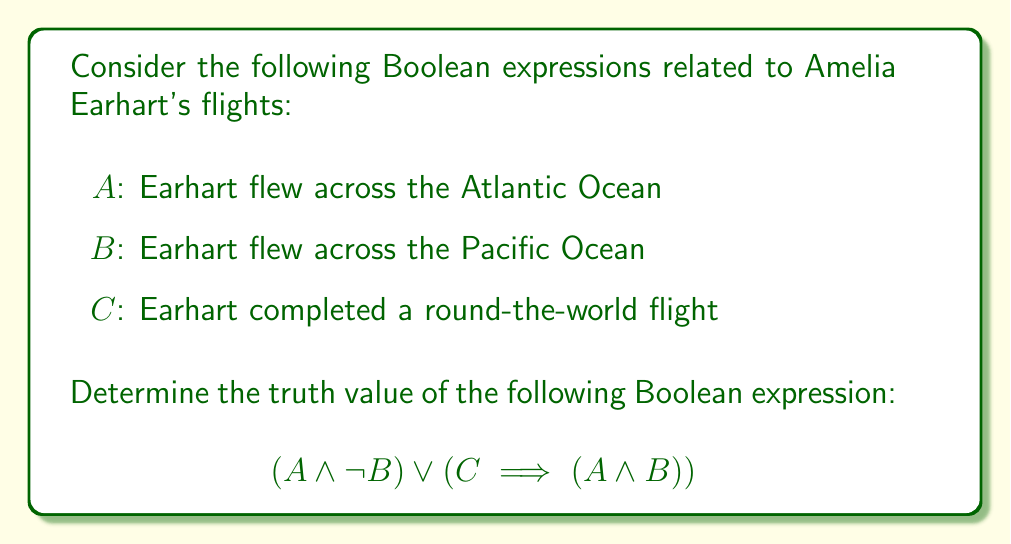Solve this math problem. Let's evaluate this Boolean expression step-by-step:

1. First, we need to determine the truth values of A, B, and C:
   A: True (Earhart flew across the Atlantic in 1932)
   B: False (Earhart never completed a flight across the Pacific)
   C: False (Earhart disappeared during her attempt to fly around the world)

2. Let's evaluate the left side of the OR operation: $(A \land \neg B)$
   $A \land \neg B = \text{True} \land \text{True} = \text{True}$

3. Now, let's evaluate the right side: $(C \implies (A \land B))$
   - First, $A \land B = \text{True} \land \text{False} = \text{False}$
   - The implication $C \implies (A \land B)$ is equivalent to $\neg C \lor (A \land B)$
   - $\neg C \lor (A \land B) = \text{True} \lor \text{False} = \text{True}$

4. Now we have:
   $$(A \land \neg B) \lor (C \implies (A \land B)) = \text{True} \lor \text{True}$$

5. The final result is:
   $$\text{True} \lor \text{True} = \text{True}$$

Therefore, the entire Boolean expression evaluates to True.
Answer: True 